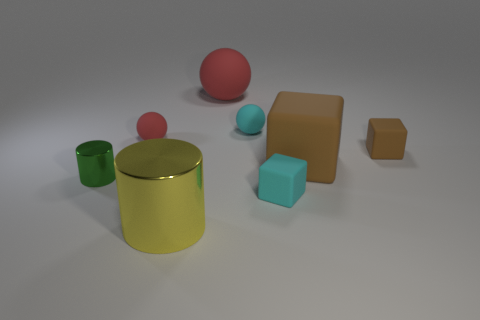There is a tiny matte ball to the right of the ball left of the large red sphere; is there a thing that is in front of it?
Keep it short and to the point. Yes. There is a large metal cylinder; is its color the same as the small rubber ball left of the yellow metal cylinder?
Offer a terse response. No. What number of other spheres are the same color as the large rubber sphere?
Provide a short and direct response. 1. There is a object in front of the small block in front of the tiny shiny thing; what is its size?
Offer a very short reply. Large. How many objects are either small cyan rubber things behind the big brown block or tiny gray spheres?
Your answer should be compact. 1. Is there a yellow cylinder of the same size as the cyan sphere?
Offer a terse response. No. Is there a tiny object behind the matte cube that is in front of the green object?
Your response must be concise. Yes. What number of cubes are shiny objects or small shiny objects?
Make the answer very short. 0. Is there another big object that has the same shape as the green metal object?
Provide a short and direct response. Yes. What shape is the large yellow thing?
Provide a succinct answer. Cylinder. 